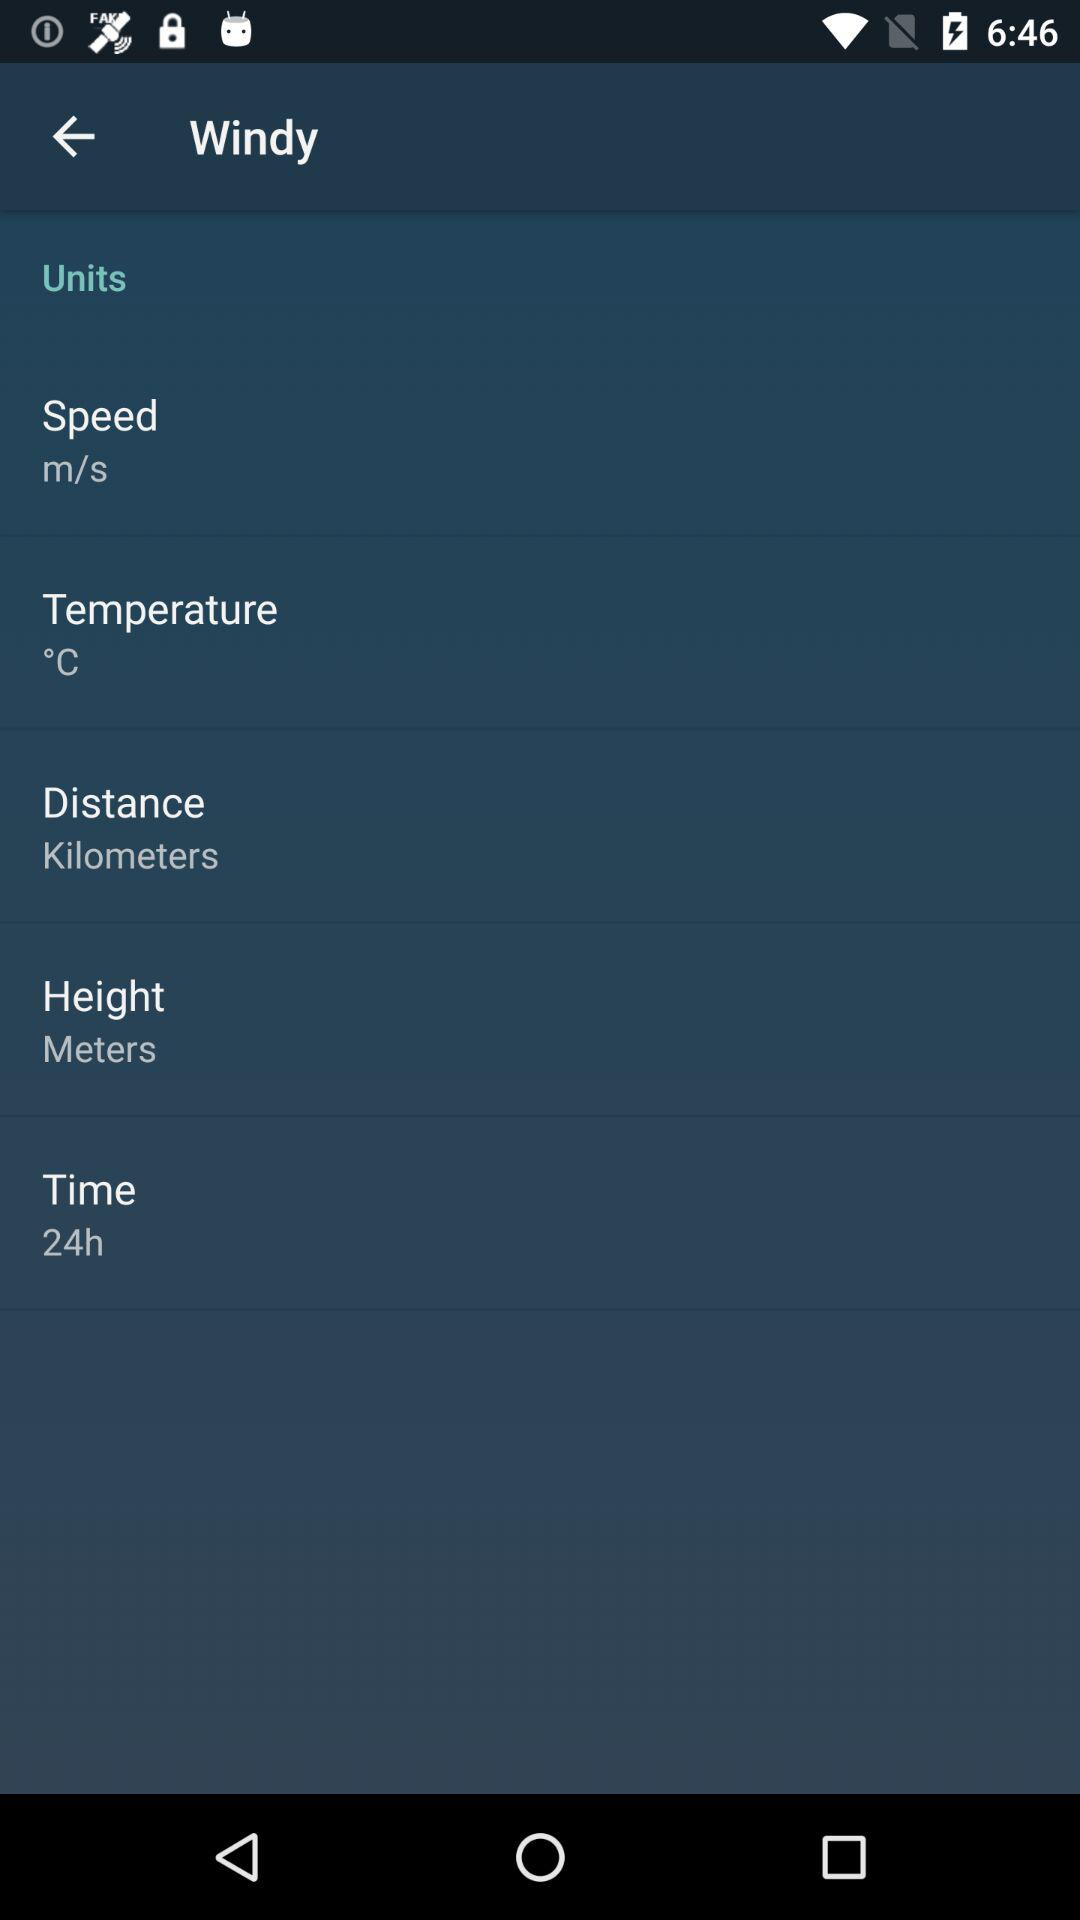What is the mentioned time format? The mentioned time format is 24 hours. 